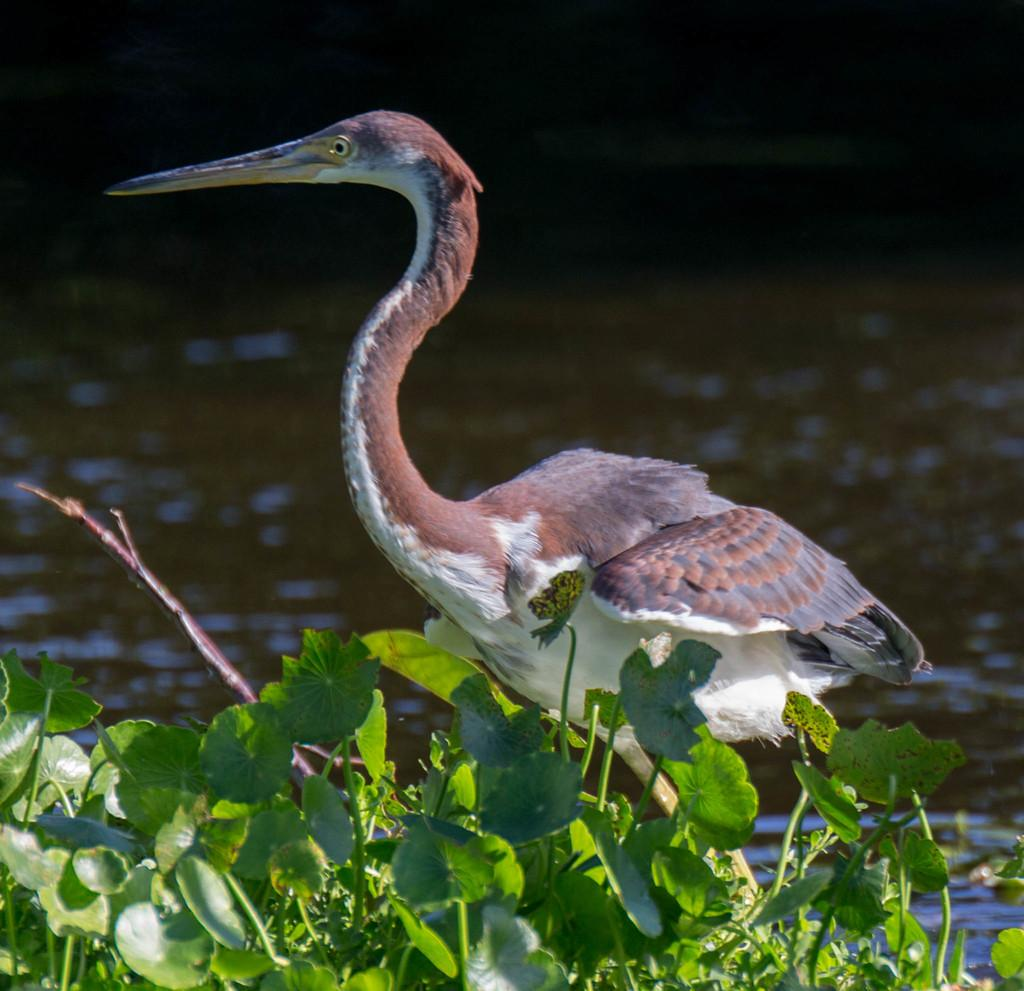What type of animal can be seen in the image? There is a bird in the image. What else is present in the image besides the bird? There are plants in the image. What can be seen in the background of the image? There is water visible in the background of the image. What type of disease is affecting the bird in the image? There is no indication of any disease affecting the bird in the image. The bird appears to be healthy and in its natural environment. 